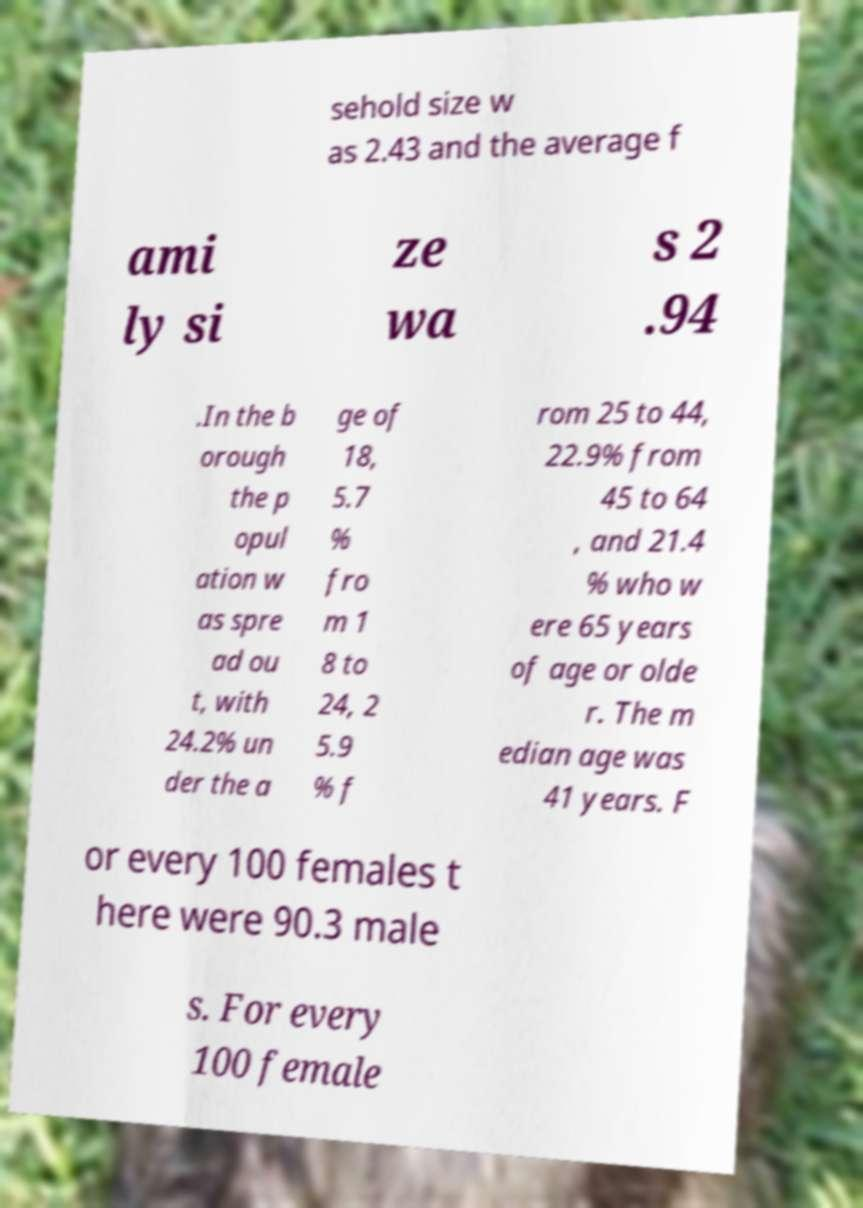Could you assist in decoding the text presented in this image and type it out clearly? sehold size w as 2.43 and the average f ami ly si ze wa s 2 .94 .In the b orough the p opul ation w as spre ad ou t, with 24.2% un der the a ge of 18, 5.7 % fro m 1 8 to 24, 2 5.9 % f rom 25 to 44, 22.9% from 45 to 64 , and 21.4 % who w ere 65 years of age or olde r. The m edian age was 41 years. F or every 100 females t here were 90.3 male s. For every 100 female 